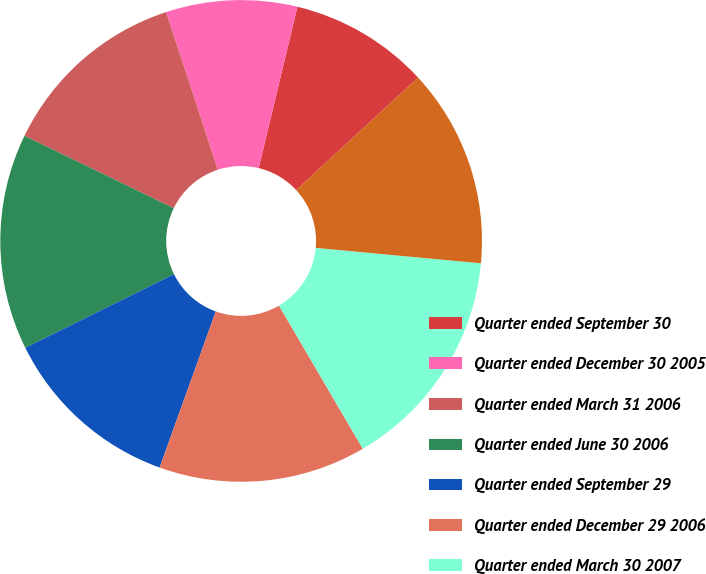<chart> <loc_0><loc_0><loc_500><loc_500><pie_chart><fcel>Quarter ended September 30<fcel>Quarter ended December 30 2005<fcel>Quarter ended March 31 2006<fcel>Quarter ended June 30 2006<fcel>Quarter ended September 29<fcel>Quarter ended December 29 2006<fcel>Quarter ended March 30 2007<fcel>Quarter ended June 29 2007<nl><fcel>9.38%<fcel>8.8%<fcel>12.77%<fcel>14.51%<fcel>12.19%<fcel>13.93%<fcel>15.09%<fcel>13.35%<nl></chart> 